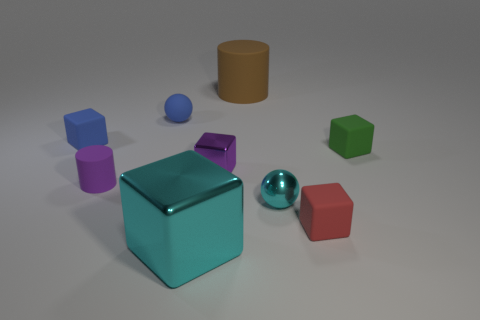Subtract 1 blocks. How many blocks are left? 4 Subtract all red cubes. How many cubes are left? 4 Subtract all yellow cubes. Subtract all cyan spheres. How many cubes are left? 5 Add 1 cyan spheres. How many objects exist? 10 Subtract all cubes. How many objects are left? 4 Subtract 0 red cylinders. How many objects are left? 9 Subtract all tiny balls. Subtract all green blocks. How many objects are left? 6 Add 9 tiny matte balls. How many tiny matte balls are left? 10 Add 5 small shiny cylinders. How many small shiny cylinders exist? 5 